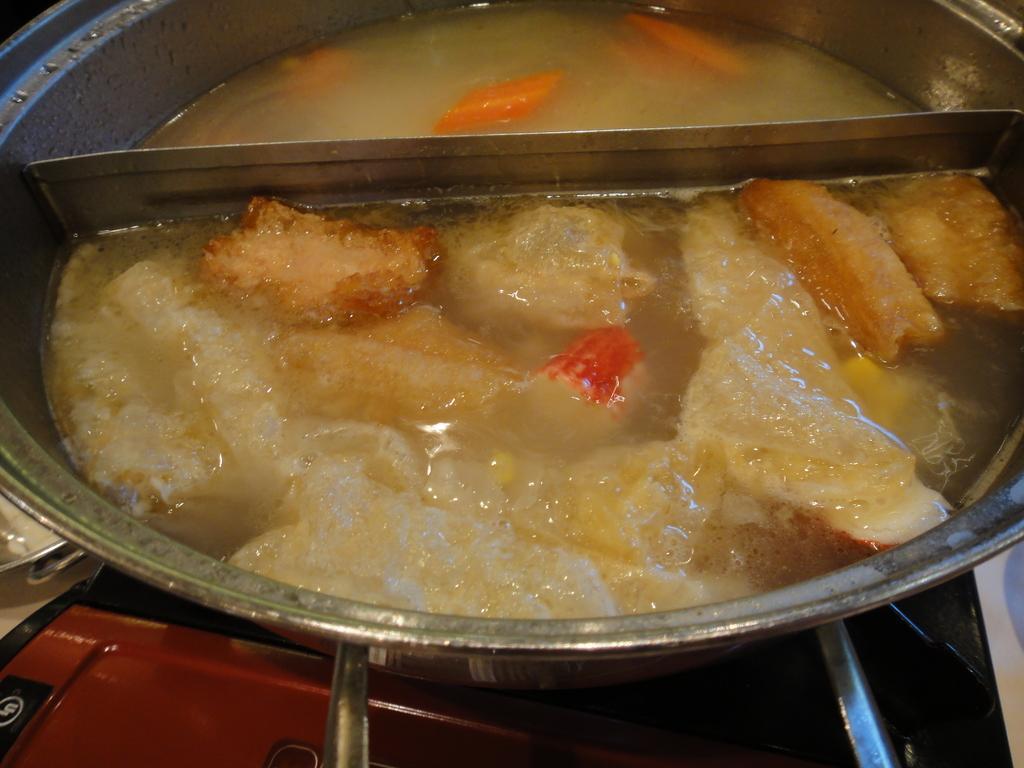In one or two sentences, can you explain what this image depicts? In this picture we can see container with food on stove. 